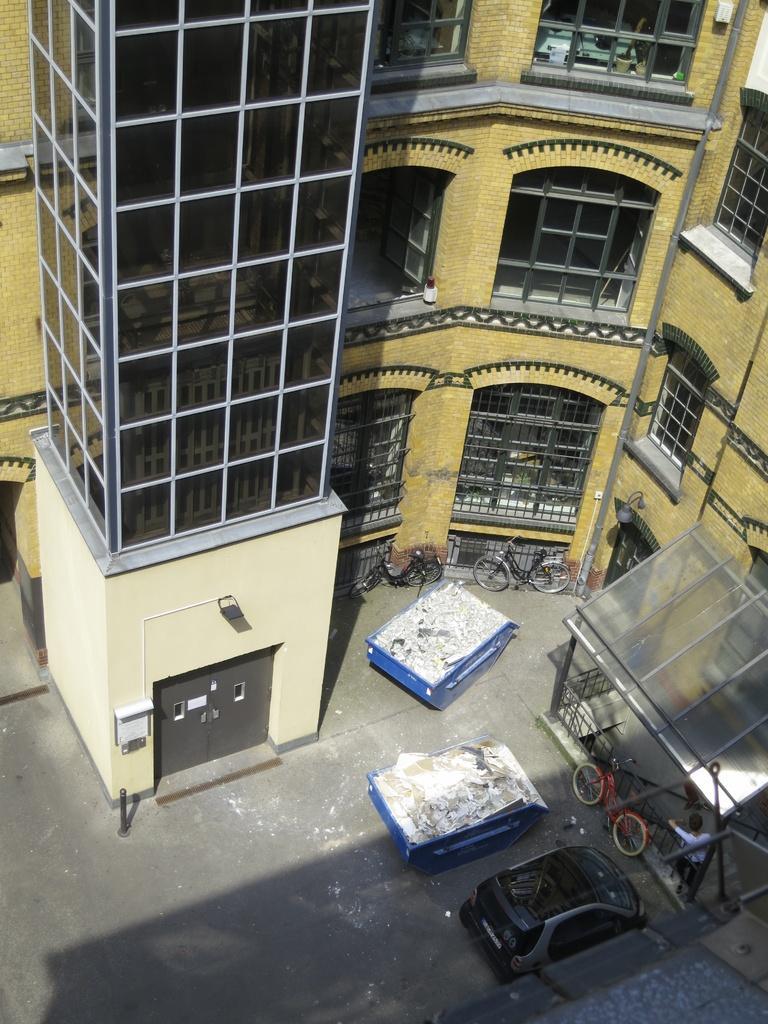Could you give a brief overview of what you see in this image? In the image there is a building with walls, windows, glasses, arches and also there are doors. On the ground there are few objects and also there is a car. There are bicycles on the ground. There is a roof with rods. 